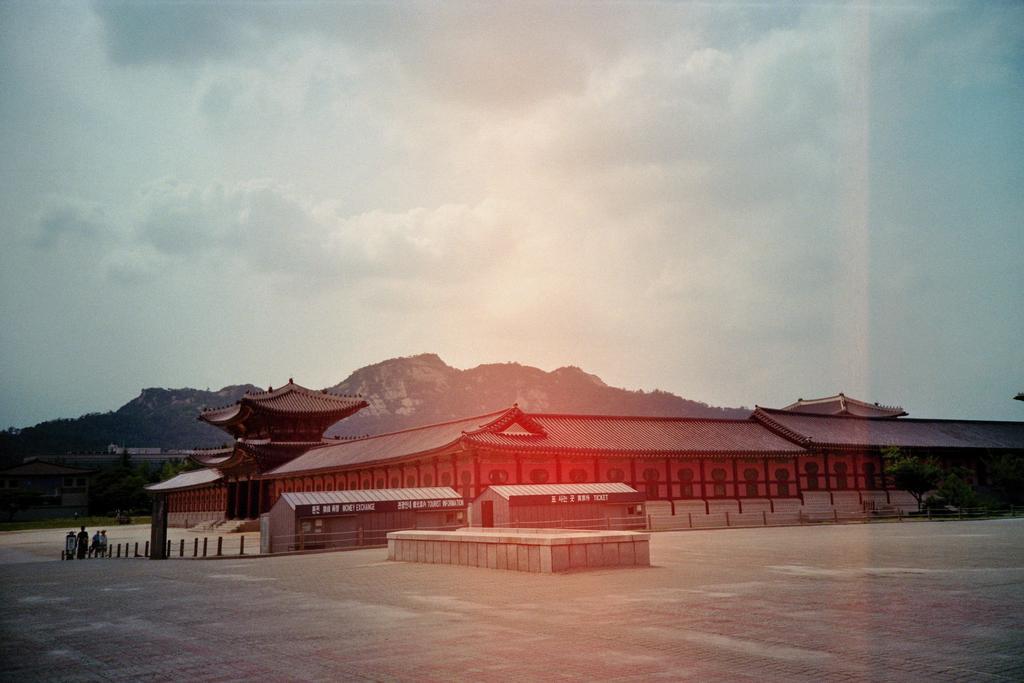Describe this image in one or two sentences. In this image in the center there is building and there are house, on the left side there are some people walking and there are some rods. At the bottom there is a walkway, and in the background there are mountains and trees. At the top there is sky. 